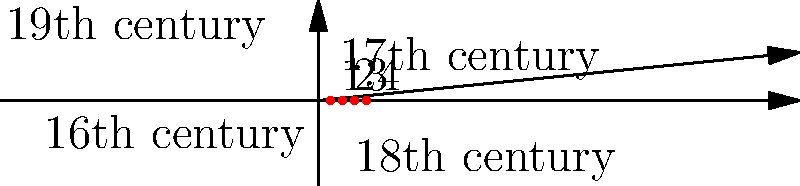In the spiral coordinate system shown, which point represents the era when crown jewels typically featured more ornate and elaborate designs, often incorporating large gemstones and intricate metalwork? To answer this question, we need to consider the evolution of crown jewel designs through the centuries:

1. The spiral starts at the origin (16th century) and moves outward counterclockwise.
2. Each numbered point represents a century, from 1 (16th century) to 4 (19th century).
3. Crown jewel designs evolved over time:
   - 16th century (point 1): Relatively simple designs
   - 17th century (point 2): Increasing complexity
   - 18th century (point 3): Peak of ornate and elaborate designs
   - 19th century (point 4): Trend towards more restrained designs

4. The 18th century (point 3) is known for the most ornate and elaborate crown jewel designs, featuring large gemstones and intricate metalwork. This was the era of Baroque and Rococo styles, which emphasized grandeur and opulence.

5. Therefore, point 3 on the spiral represents the era of the most ornate crown jewel designs.
Answer: Point 3 